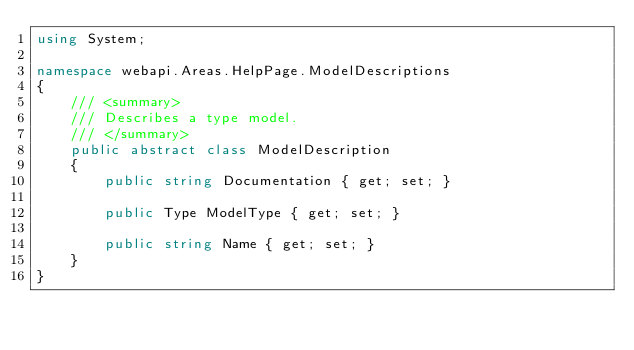Convert code to text. <code><loc_0><loc_0><loc_500><loc_500><_C#_>using System;

namespace webapi.Areas.HelpPage.ModelDescriptions
{
    /// <summary>
    /// Describes a type model.
    /// </summary>
    public abstract class ModelDescription
    {
        public string Documentation { get; set; }

        public Type ModelType { get; set; }

        public string Name { get; set; }
    }
}</code> 